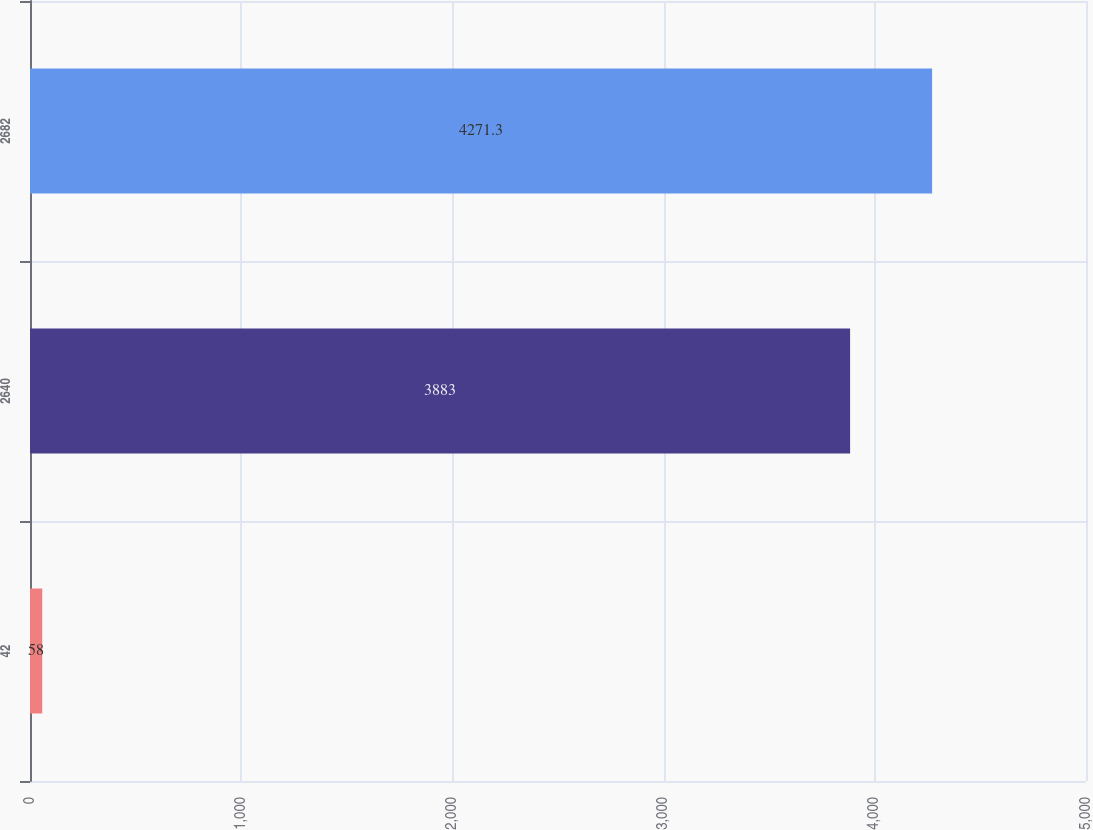<chart> <loc_0><loc_0><loc_500><loc_500><bar_chart><fcel>42<fcel>2640<fcel>2682<nl><fcel>58<fcel>3883<fcel>4271.3<nl></chart> 